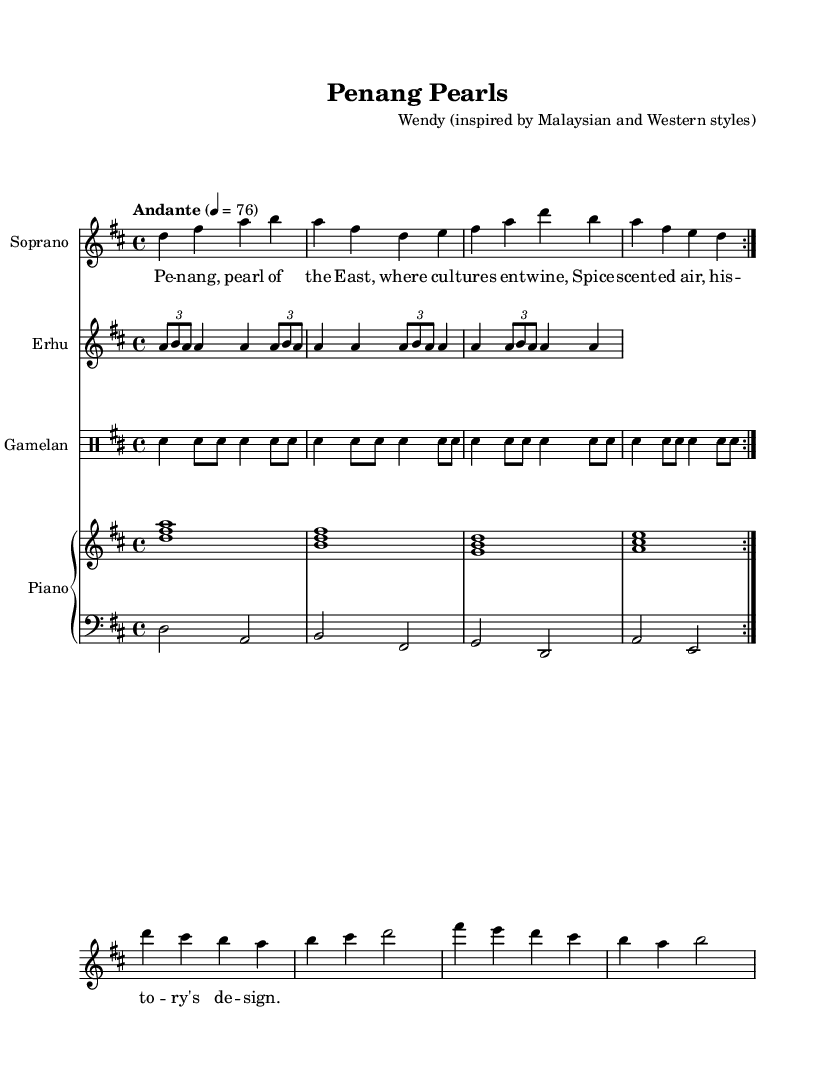What is the key signature of this music? The key signature is two sharps, indicating that it is in the key of D major. The presence of both C sharp and F sharp can be recognized by looking at the beginning of the staff where the key signature is indicated.
Answer: D major What is the time signature of this music? The time signature is found right after the clef at the start of the piece, which shows four beats per measure. It is indicated by the numbers 4 over 4, meaning there are four quarter-note beats in each measure.
Answer: 4/4 What tempo marking is indicated for this piece? The tempo marking appears above the staff, stating "Andante" with a metronome mark of 76. This indicates a moderate pace. The "Andante" term suggests a walking speed, while the number specifies the actual tempo.
Answer: Andante, 76 How many voices are utilized in this score? The score includes a total of four distinct voices: Soprano, Erhu, Gamelan, and Piano (which is divided into two staves for right and left hands). Each part is clearly identified with instrument names in the scored sections.
Answer: Four What type of opera is represented in this sheet music? The music represents a Malaysian-inspired fusion opera, which combines traditional Malaysian musical elements with Western styles. This can be inferred from the title and cultural references expressed through the instruments and lyrical content.
Answer: Malaysian-inspired fusion opera In which measure does the soprano part repeat? The soprano part indicates a repetition with the instruction "repeat volta 2," which means the section from measures 1 to 4 will be played twice. This type of marking specifies to return to the designated section after the first play.
Answer: Measures 1 to 4 